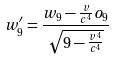<formula> <loc_0><loc_0><loc_500><loc_500>w _ { 9 } ^ { \prime } = \frac { w _ { 9 } - \frac { v } { c ^ { 4 } } o _ { 9 } } { \sqrt { 9 - \frac { v ^ { 4 } } { c ^ { 4 } } } }</formula> 